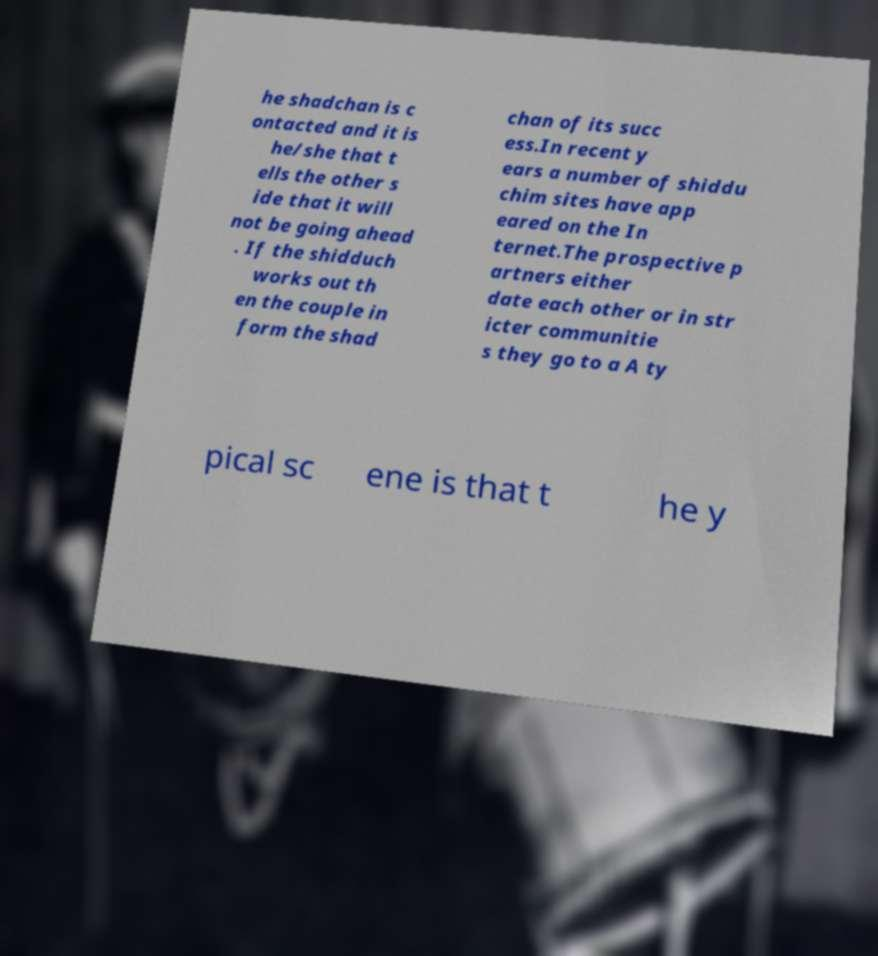Please identify and transcribe the text found in this image. he shadchan is c ontacted and it is he/she that t ells the other s ide that it will not be going ahead . If the shidduch works out th en the couple in form the shad chan of its succ ess.In recent y ears a number of shiddu chim sites have app eared on the In ternet.The prospective p artners either date each other or in str icter communitie s they go to a A ty pical sc ene is that t he y 